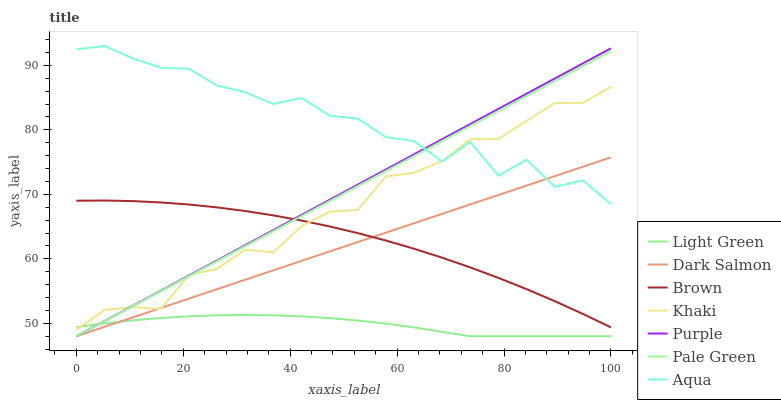Does Khaki have the minimum area under the curve?
Answer yes or no. No. Does Khaki have the maximum area under the curve?
Answer yes or no. No. Is Khaki the smoothest?
Answer yes or no. No. Is Khaki the roughest?
Answer yes or no. No. Does Khaki have the lowest value?
Answer yes or no. No. Does Khaki have the highest value?
Answer yes or no. No. Is Brown less than Aqua?
Answer yes or no. Yes. Is Brown greater than Light Green?
Answer yes or no. Yes. Does Brown intersect Aqua?
Answer yes or no. No. 